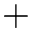<formula> <loc_0><loc_0><loc_500><loc_500>+</formula> 